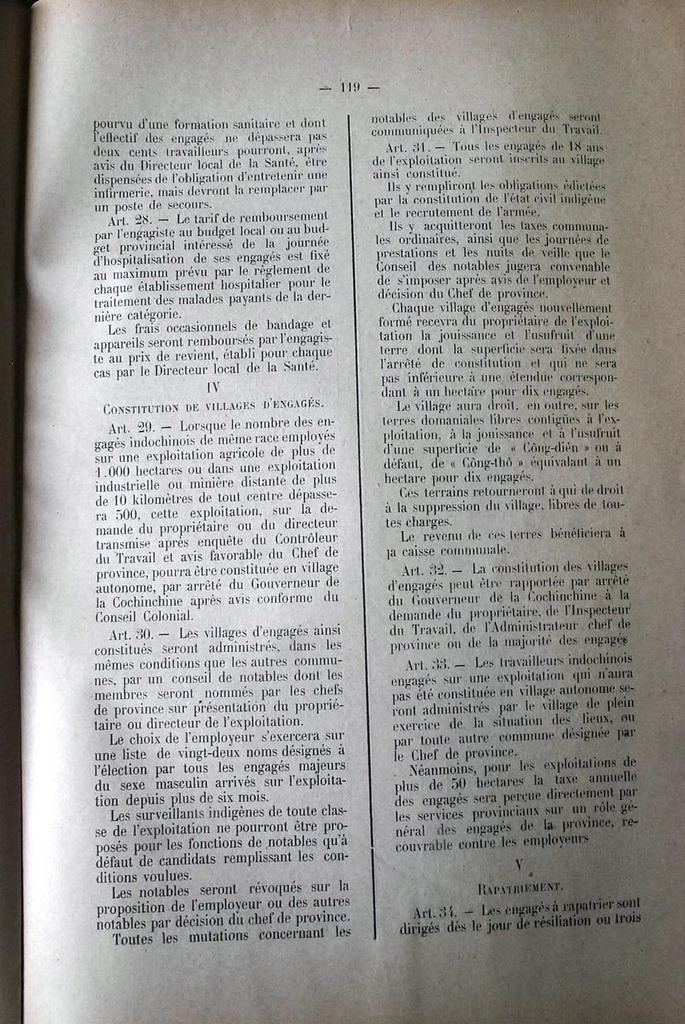Provide a one-sentence caption for the provided image. a long book sits opened to page 119. 